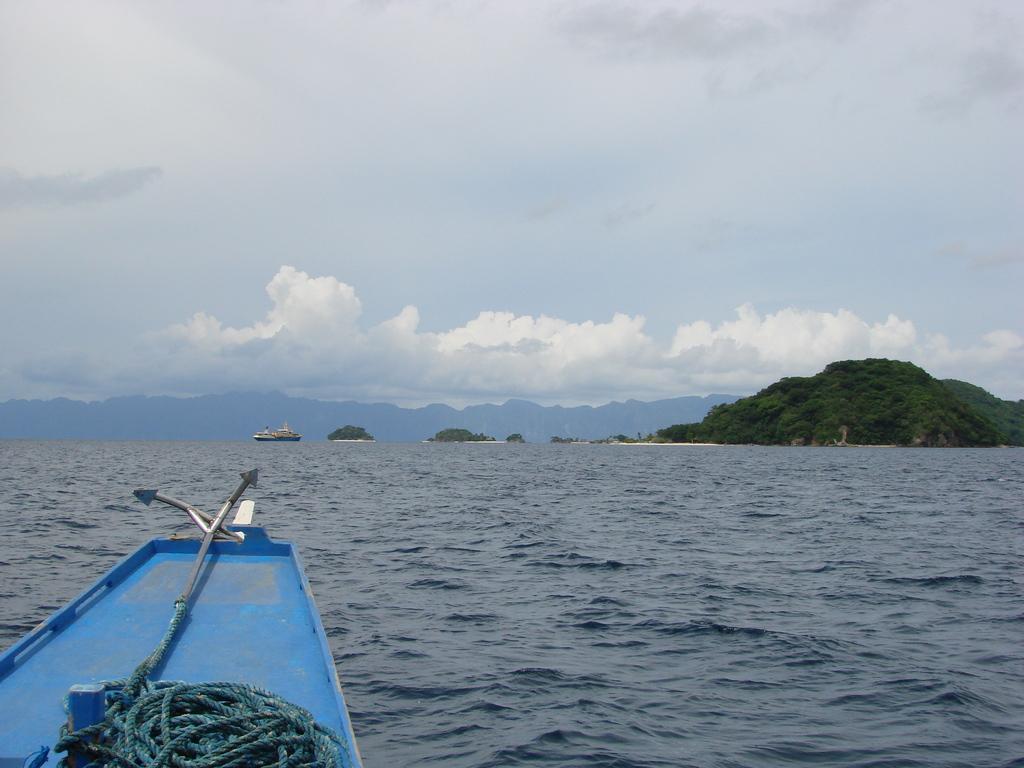Please provide a concise description of this image. In this picture we can see boats on water, ropes, trees, mountains and in the background we can see the sky with clouds. 